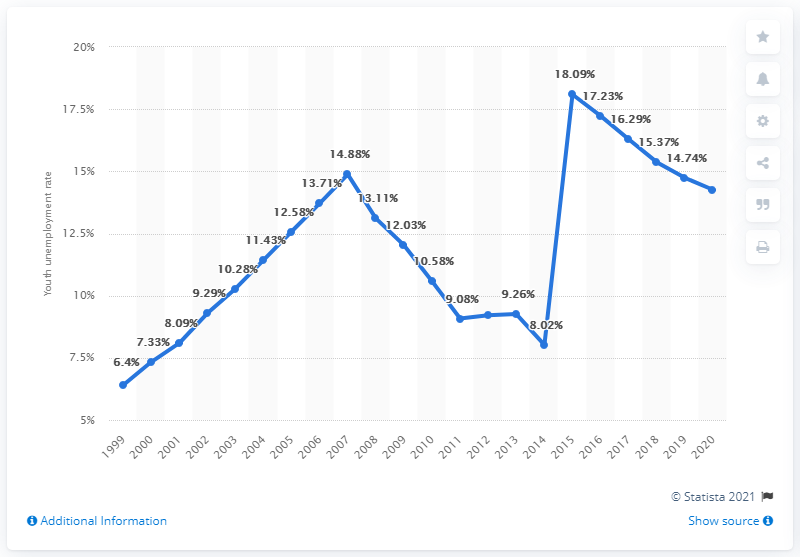Highlight a few significant elements in this photo. In 2020, the youth unemployment rate in Mali was 14.26%. 